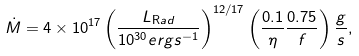Convert formula to latex. <formula><loc_0><loc_0><loc_500><loc_500>\dot { M } = 4 \times 1 0 ^ { 1 7 } \left ( \frac { L _ { \mathrm R a d } } { 1 0 ^ { 3 0 } e r g s ^ { - 1 } } \right ) ^ { 1 2 / 1 7 } \left ( \frac { 0 . 1 } { \eta } \frac { 0 . 7 5 } { f } \right ) \frac { g } { s } ,</formula> 